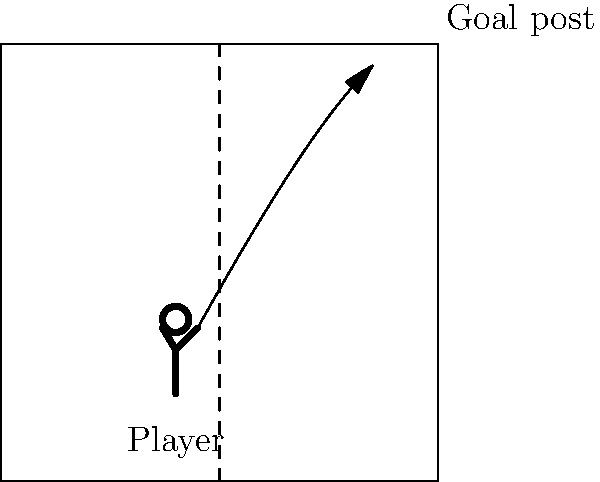Based on the diagram showing a netball player's stance and arm position, which of the following factors would most likely increase the probability of a successful shot?

A) Lowering the release point of the ball
B) Increasing the initial velocity of the ball
C) Decreasing the angle of release
D) Aiming directly at the center of the goal ring To determine the factor that would most likely increase the probability of a successful netball shot, let's analyze each option:

1. Lowering the release point of the ball:
   This would generally decrease the chances of success, as it reduces the optimal trajectory for the ball to enter the goal.

2. Increasing the initial velocity of the ball:
   This factor can improve the shot's success rate. A higher initial velocity allows for:
   a) A more direct path to the goal
   b) Less time for external factors (like wind) to affect the ball's trajectory
   c) Reduced impact of gravity on the ball's path

3. Decreasing the angle of release:
   This would likely reduce the chances of success, as it may result in a trajectory that's too low, increasing the risk of the ball hitting the rim or missing entirely.

4. Aiming directly at the center of the goal ring:
   While this might seem logical, it doesn't necessarily increase the probability of a successful shot. The optimal aiming point often depends on the player's position and the shot's arc.

Among these options, increasing the initial velocity of the ball (option B) is the most likely to improve shot accuracy and success rate. This is because it allows for a more optimal trajectory, reducing the effects of gravity and external factors on the ball's path to the goal.

In netball, players often aim for a high arc to increase the ball's chances of entering the goal. The initial velocity plays a crucial role in achieving this optimal arc while maintaining accuracy.
Answer: B) Increasing the initial velocity of the ball 